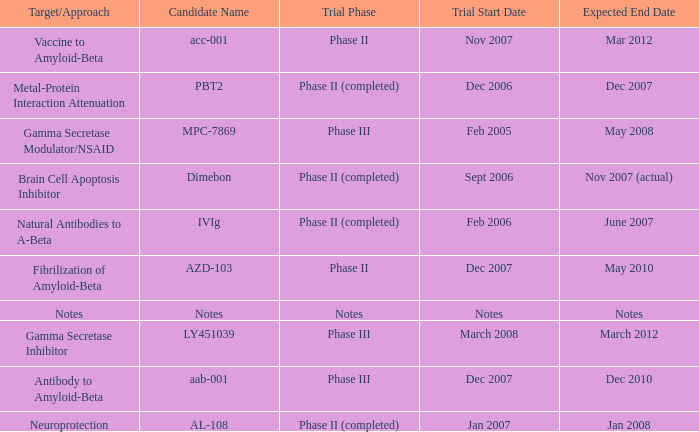What is Trial Start Date, when Candidate Name is PBT2? Dec 2006. 